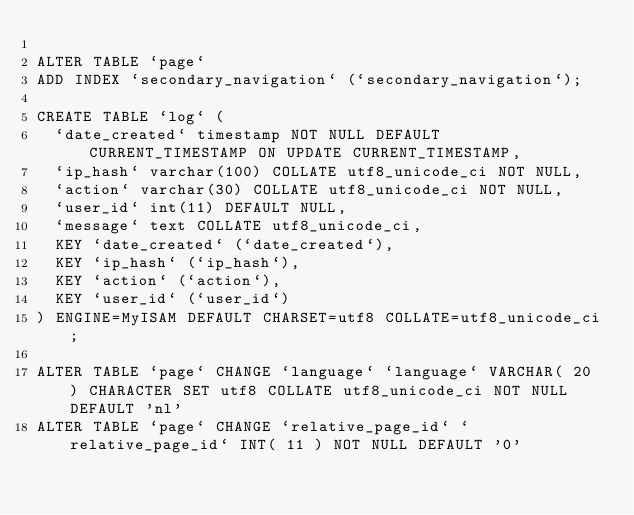Convert code to text. <code><loc_0><loc_0><loc_500><loc_500><_SQL_>
ALTER TABLE `page`
ADD INDEX `secondary_navigation` (`secondary_navigation`);

CREATE TABLE `log` (
  `date_created` timestamp NOT NULL DEFAULT CURRENT_TIMESTAMP ON UPDATE CURRENT_TIMESTAMP,
  `ip_hash` varchar(100) COLLATE utf8_unicode_ci NOT NULL,
  `action` varchar(30) COLLATE utf8_unicode_ci NOT NULL,
  `user_id` int(11) DEFAULT NULL,
  `message` text COLLATE utf8_unicode_ci,
  KEY `date_created` (`date_created`),
  KEY `ip_hash` (`ip_hash`),
  KEY `action` (`action`),
  KEY `user_id` (`user_id`)
) ENGINE=MyISAM DEFAULT CHARSET=utf8 COLLATE=utf8_unicode_ci;

ALTER TABLE `page` CHANGE `language` `language` VARCHAR( 20 ) CHARACTER SET utf8 COLLATE utf8_unicode_ci NOT NULL DEFAULT 'nl'
ALTER TABLE `page` CHANGE `relative_page_id` `relative_page_id` INT( 11 ) NOT NULL DEFAULT '0'
</code> 